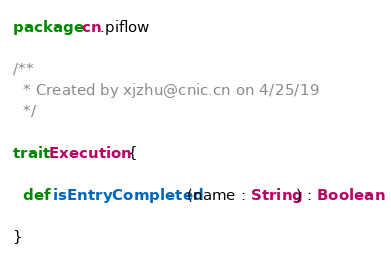<code> <loc_0><loc_0><loc_500><loc_500><_Scala_>package cn.piflow

/**
  * Created by xjzhu@cnic.cn on 4/25/19
  */

trait Execution {

  def isEntryCompleted(name : String) : Boolean

}
</code> 